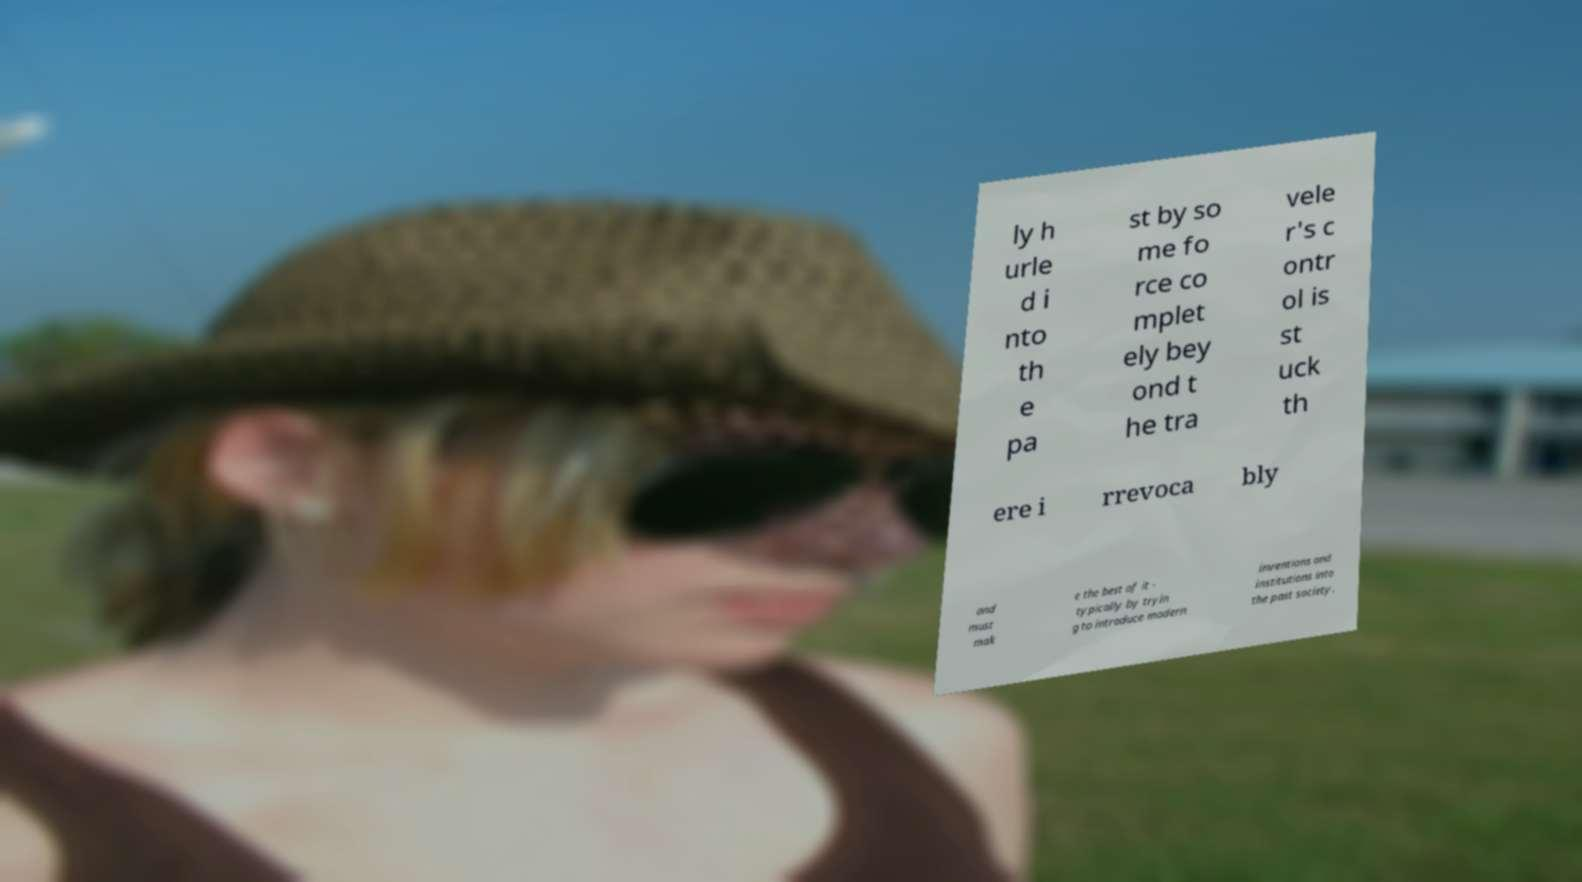Please identify and transcribe the text found in this image. ly h urle d i nto th e pa st by so me fo rce co mplet ely bey ond t he tra vele r's c ontr ol is st uck th ere i rrevoca bly and must mak e the best of it - typically by tryin g to introduce modern inventions and institutions into the past society. 